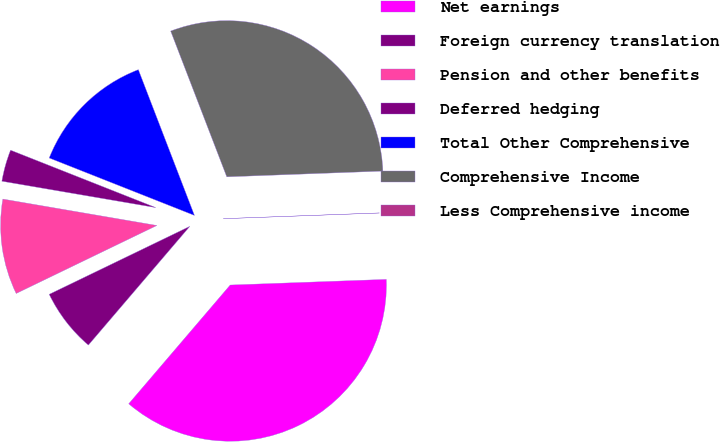Convert chart. <chart><loc_0><loc_0><loc_500><loc_500><pie_chart><fcel>Net earnings<fcel>Foreign currency translation<fcel>Pension and other benefits<fcel>Deferred hedging<fcel>Total Other Comprehensive<fcel>Comprehensive Income<fcel>Less Comprehensive income<nl><fcel>36.83%<fcel>6.58%<fcel>9.87%<fcel>3.29%<fcel>13.16%<fcel>30.26%<fcel>0.01%<nl></chart> 